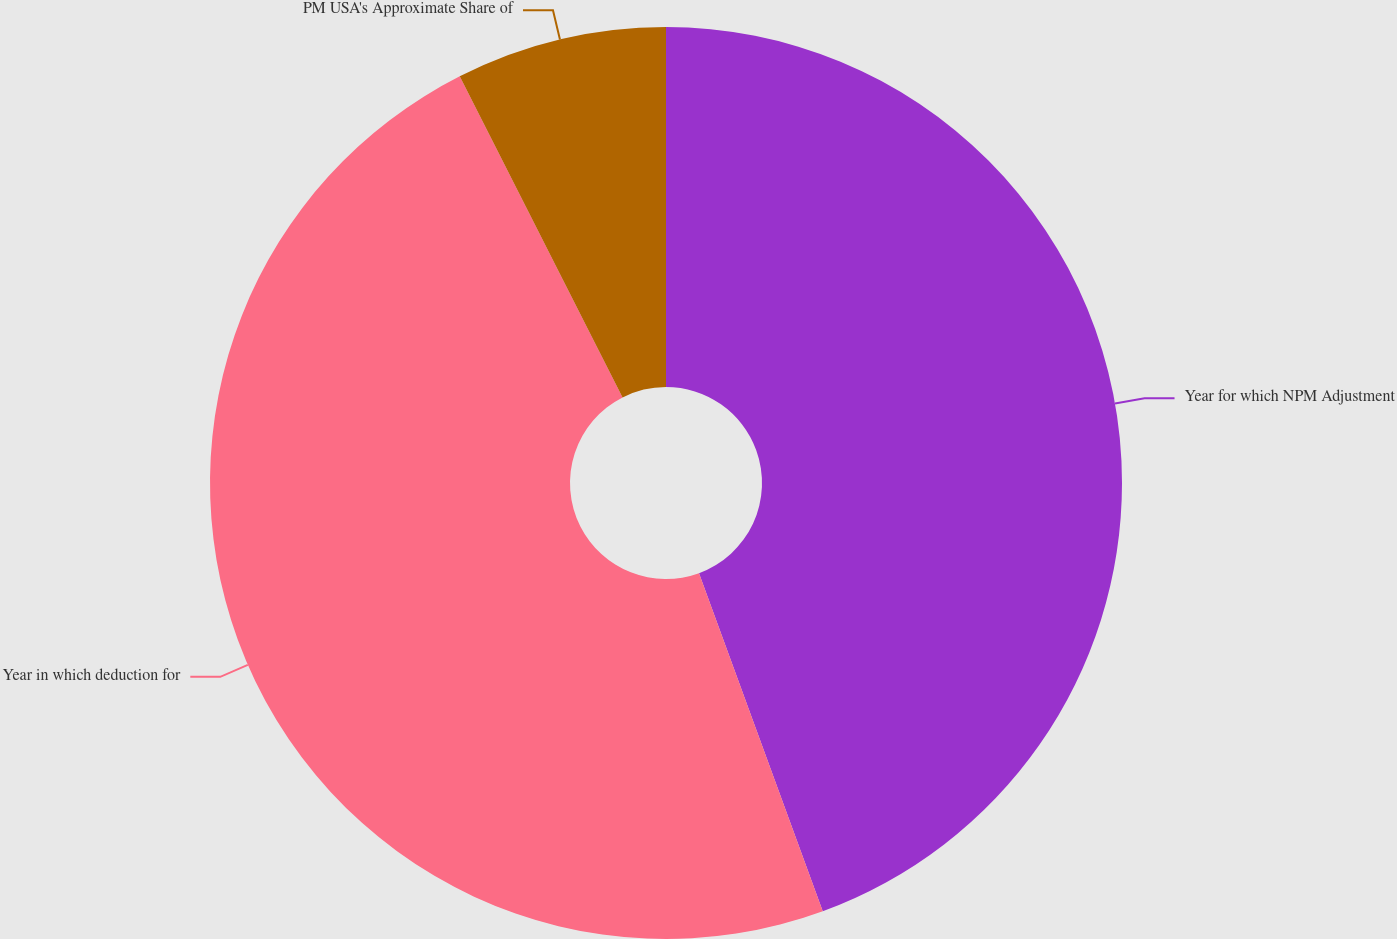Convert chart. <chart><loc_0><loc_0><loc_500><loc_500><pie_chart><fcel>Year for which NPM Adjustment<fcel>Year in which deduction for<fcel>PM USA's Approximate Share of<nl><fcel>44.41%<fcel>48.11%<fcel>7.47%<nl></chart> 